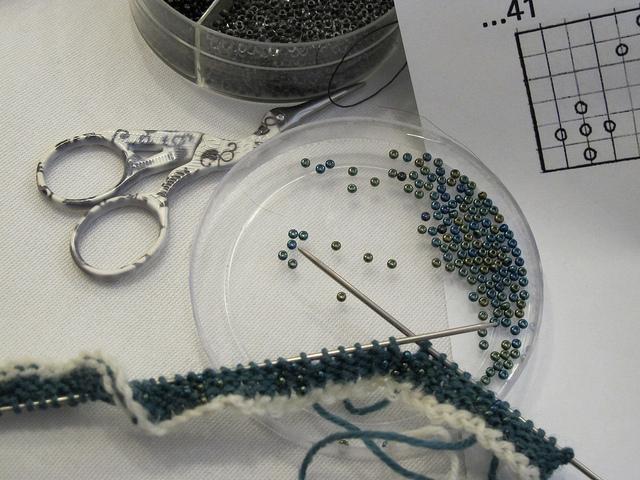What is the name of the item to the right of the pincushion?
Keep it brief. Scissors. What is in the bowl?
Write a very short answer. Beads. Is this an office desk?
Short answer required. No. The beads are resting on what?
Keep it brief. Dish. What is lying next to the bowl of beads?
Write a very short answer. Scissors. How many beads did they use?
Give a very brief answer. Lot. Is somebody knitting?
Answer briefly. Yes. 